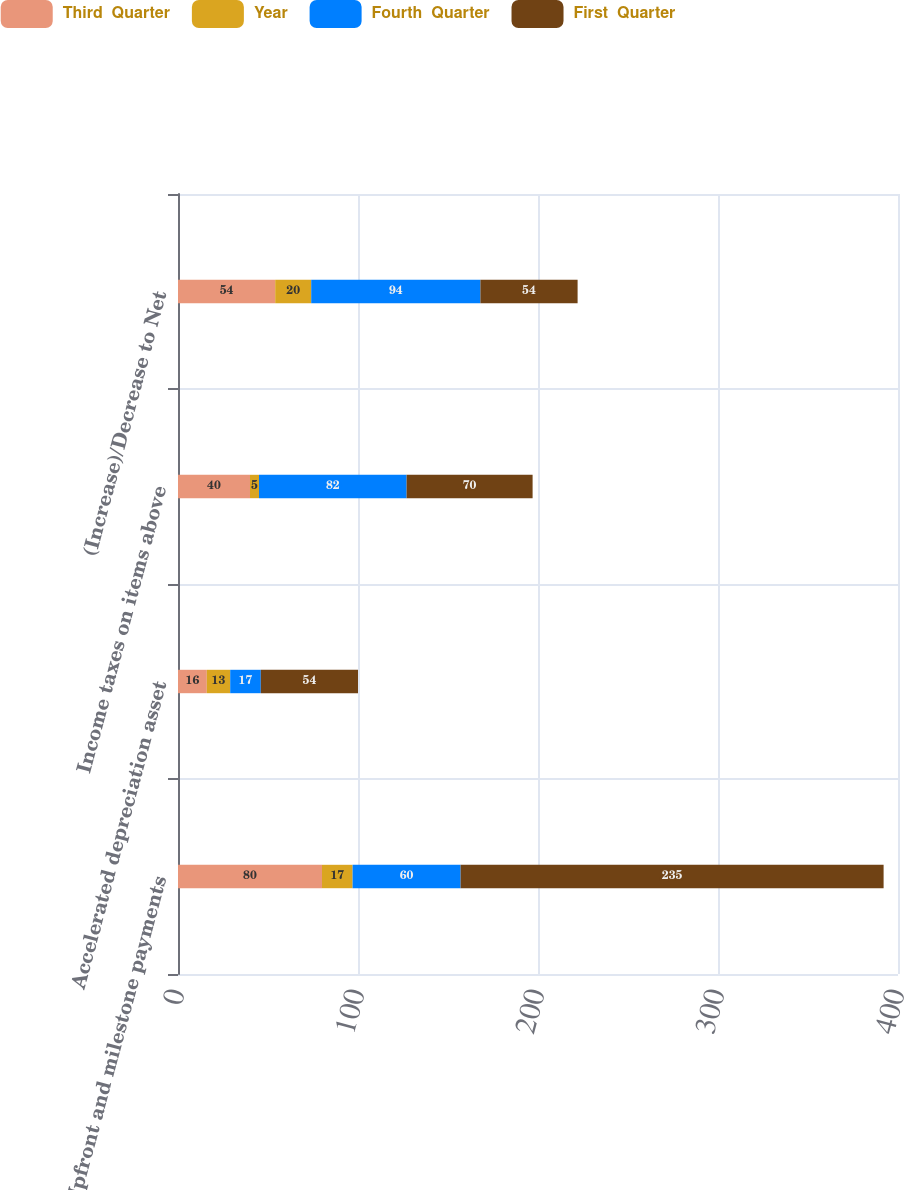Convert chart. <chart><loc_0><loc_0><loc_500><loc_500><stacked_bar_chart><ecel><fcel>Upfront and milestone payments<fcel>Accelerated depreciation asset<fcel>Income taxes on items above<fcel>(Increase)/Decrease to Net<nl><fcel>Third  Quarter<fcel>80<fcel>16<fcel>40<fcel>54<nl><fcel>Year<fcel>17<fcel>13<fcel>5<fcel>20<nl><fcel>Fourth  Quarter<fcel>60<fcel>17<fcel>82<fcel>94<nl><fcel>First  Quarter<fcel>235<fcel>54<fcel>70<fcel>54<nl></chart> 